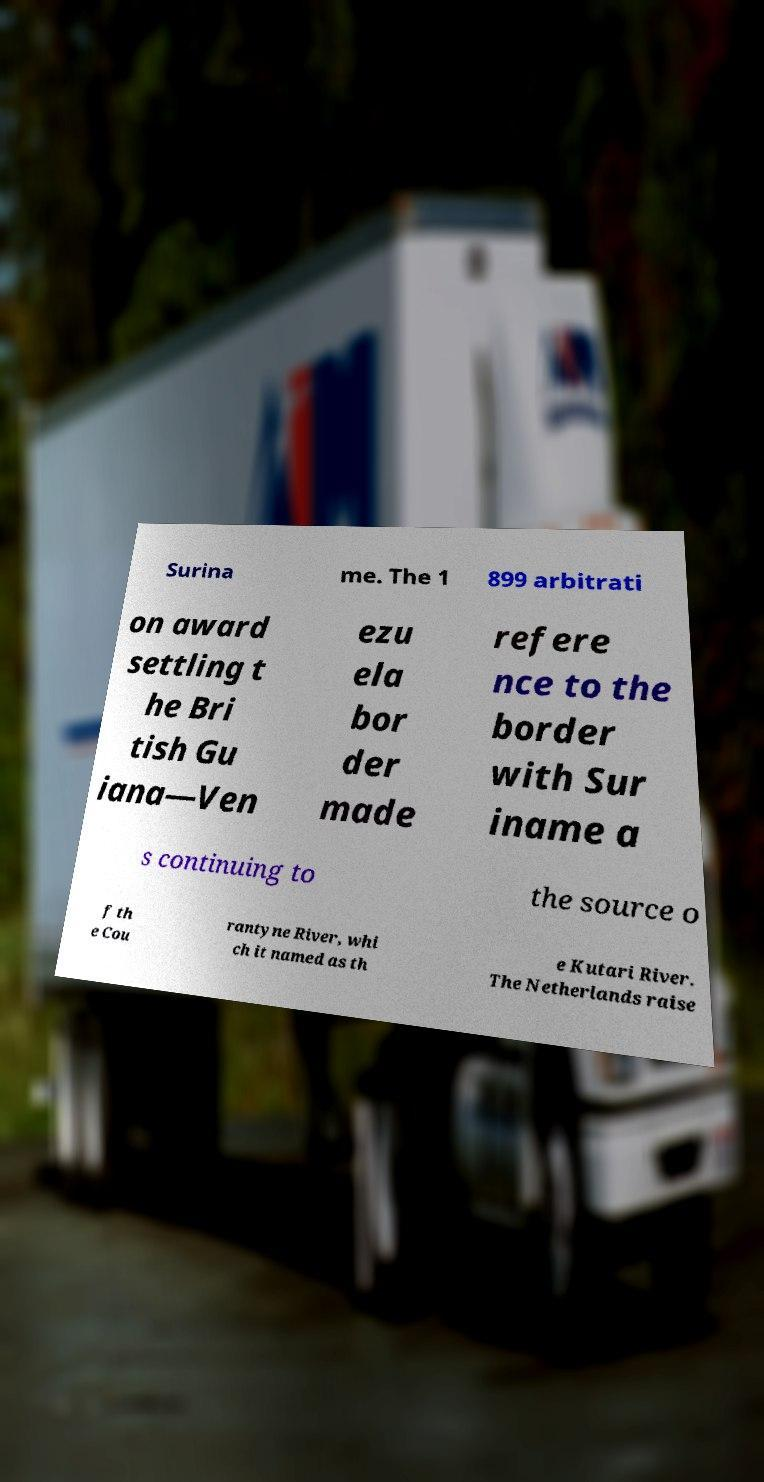For documentation purposes, I need the text within this image transcribed. Could you provide that? Surina me. The 1 899 arbitrati on award settling t he Bri tish Gu iana—Ven ezu ela bor der made refere nce to the border with Sur iname a s continuing to the source o f th e Cou rantyne River, whi ch it named as th e Kutari River. The Netherlands raise 